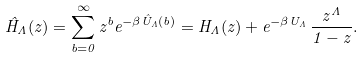<formula> <loc_0><loc_0><loc_500><loc_500>\hat { H } _ { \Lambda } ( z ) = \sum _ { b = 0 } ^ { \infty } z ^ { b } e ^ { - \beta \hat { U } _ { \Lambda } ( b ) } = H _ { \Lambda } ( z ) + e ^ { - \beta U _ { \Lambda } } \, \frac { z ^ { \Lambda } } { 1 - z } .</formula> 